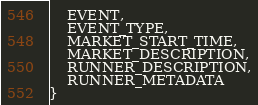<code> <loc_0><loc_0><loc_500><loc_500><_Kotlin_>    EVENT,
    EVENT_TYPE,
    MARKET_START_TIME,
    MARKET_DESCRIPTION,
    RUNNER_DESCRIPTION,
    RUNNER_METADATA
}
</code> 